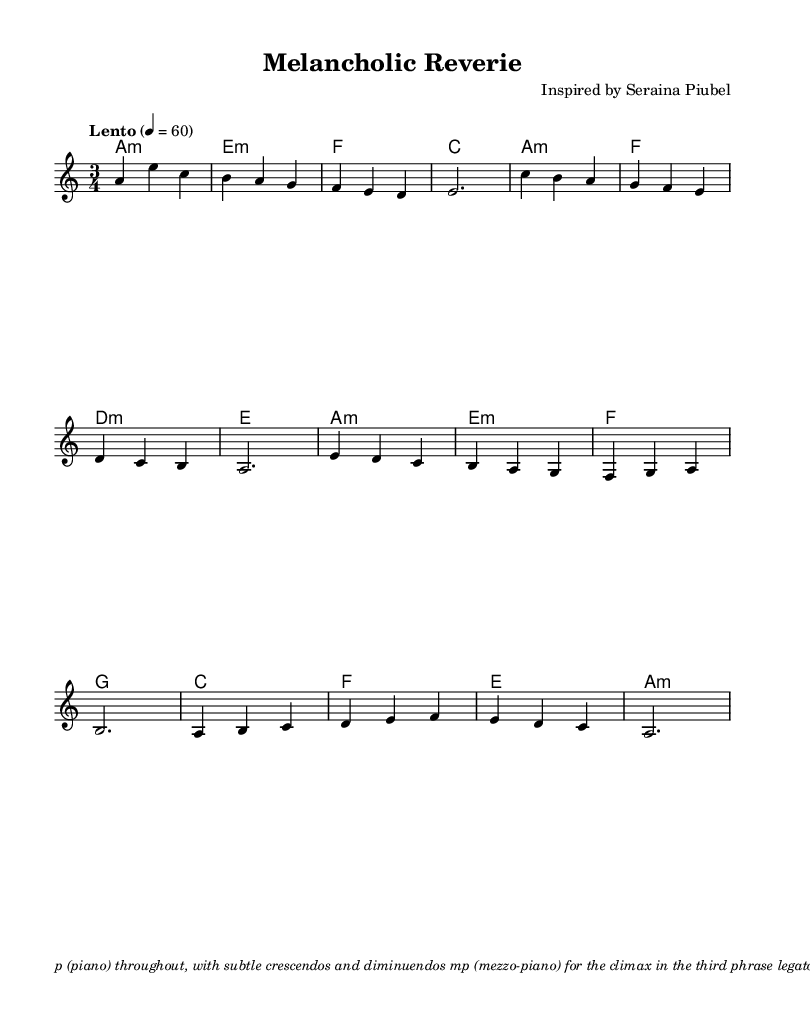What is the key signature of this piece? The key signature is indicated at the beginning of the score, showing one flat, which corresponds to A minor.
Answer: A minor What is the time signature of this composition? The time signature is found in the opening measures, represented as 3/4, indicating three beats per measure.
Answer: 3/4 What is the tempo marking for this piece? The tempo marking is provided in the score, indicating "Lento" with a metronome marking of 60 beats per minute, suggesting a slow tempo.
Answer: Lento, 60 How many measures are in the melody section? The melody section can be counted by evaluating each line of the music until the end, which totals 12 measures.
Answer: 12 What dynamic instruction is given for the climax in the music? The dynamic instruction for the climax is labeled as "mp," meaning mezzo-piano, which indicates a moderately soft volume for that section.
Answer: mp What texture is suggested for performance with the soft pedal? The instruction states "una corda" which indicates the use of the soft pedal, creating a delicate tone color, specifically meant for nuanced playing.
Answer: una corda 